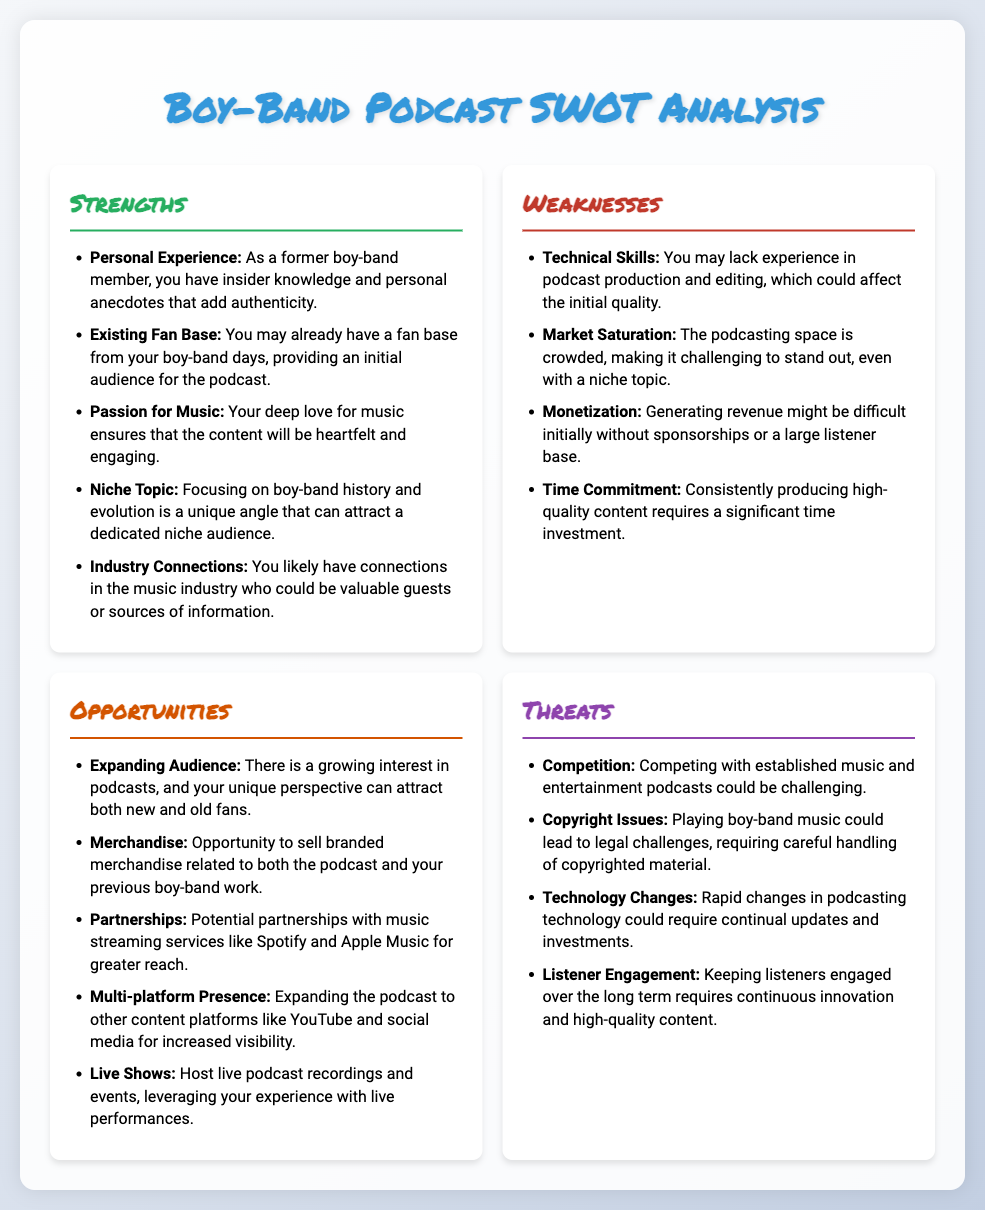What is one strength related to insider knowledge? The strength includes personal experience as a former boy-band member, offering insider knowledge and anecdotes.
Answer: Personal Experience How many weaknesses are listed in the document? The document lists four weaknesses in the weaknesses section.
Answer: 4 What is an opportunity related to the audience? An opportunity mentioned is the potential for expanding the audience due to growing interest in podcasts.
Answer: Expanding Audience Which threat involves legal issues? The threat concerning copyright issues directly involves legal challenges related to music usage.
Answer: Copyright Issues What is the specific niche topic of the podcast? The podcast will focus on the history and evolution of boy-bands.
Answer: Boy-Band History and Evolution What strength indicates a benefit from past fame? The existing fan base can provide an initial audience for the podcast.
Answer: Existing Fan Base What opportunity involves partnerships? There is a potential for partnerships with music streaming services.
Answer: Partnerships What is the primary challenge mentioned in the threats section? Competing with established music and entertainment podcasts poses a significant challenge.
Answer: Competition 